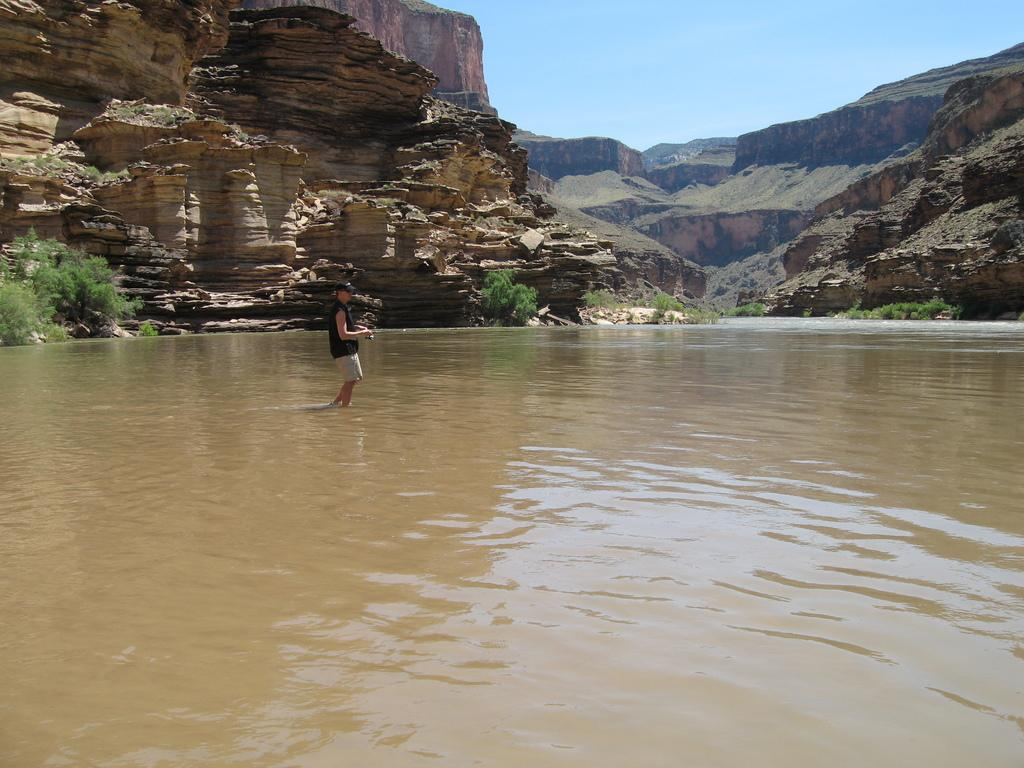Where was the image taken? The image was clicked outside. What can be seen on the left side of the image? There are bushes on the left side of the image. What is in the middle of the image? There is water in the middle of the image. Can you describe the person in the image? There is a person standing in the middle of the image. What is visible at the top of the image? The sky is visible at the top of the image. What brand of toothpaste is the person using in the image? There is no toothpaste present in the image, and the person's activities are not mentioned. 